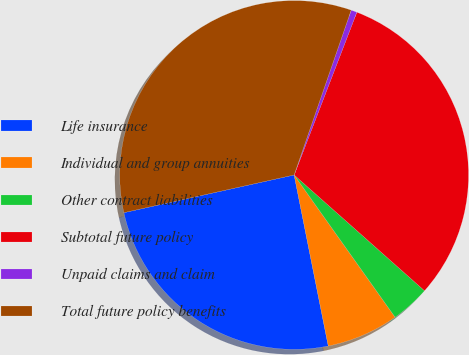<chart> <loc_0><loc_0><loc_500><loc_500><pie_chart><fcel>Life insurance<fcel>Individual and group annuities<fcel>Other contract liabilities<fcel>Subtotal future policy<fcel>Unpaid claims and claim<fcel>Total future policy benefits<nl><fcel>24.67%<fcel>6.69%<fcel>3.62%<fcel>30.71%<fcel>0.55%<fcel>33.78%<nl></chart> 